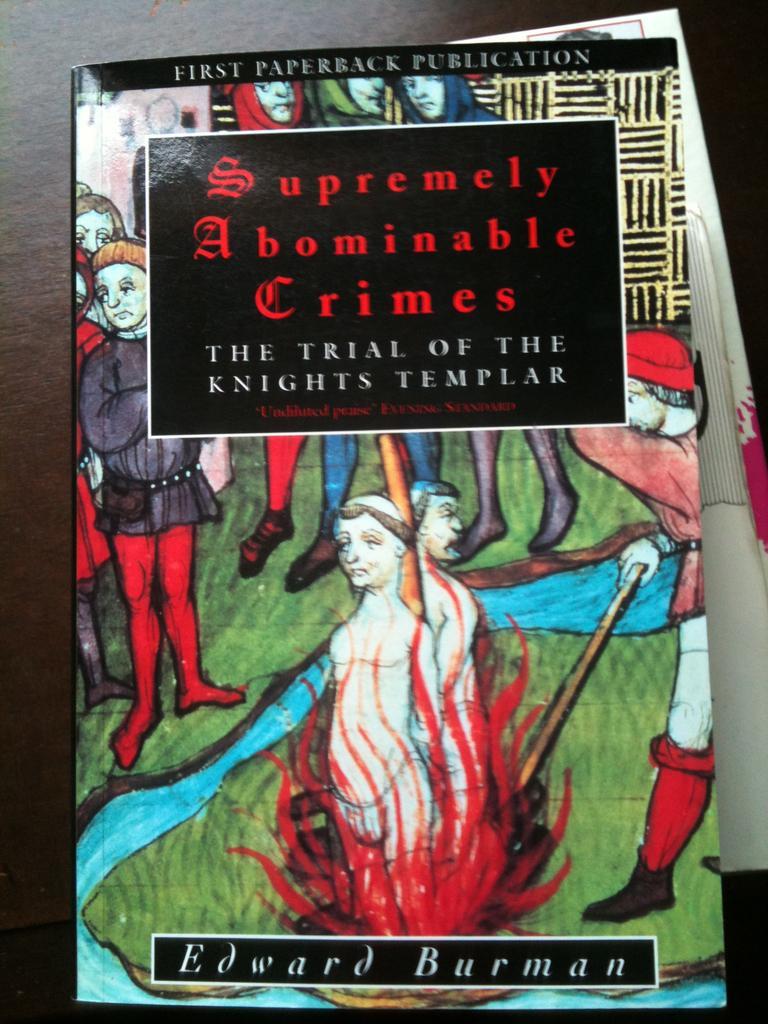How would you summarize this image in a sentence or two? As we can see in the image there is a poster. On poster there is grass, water and few people. 